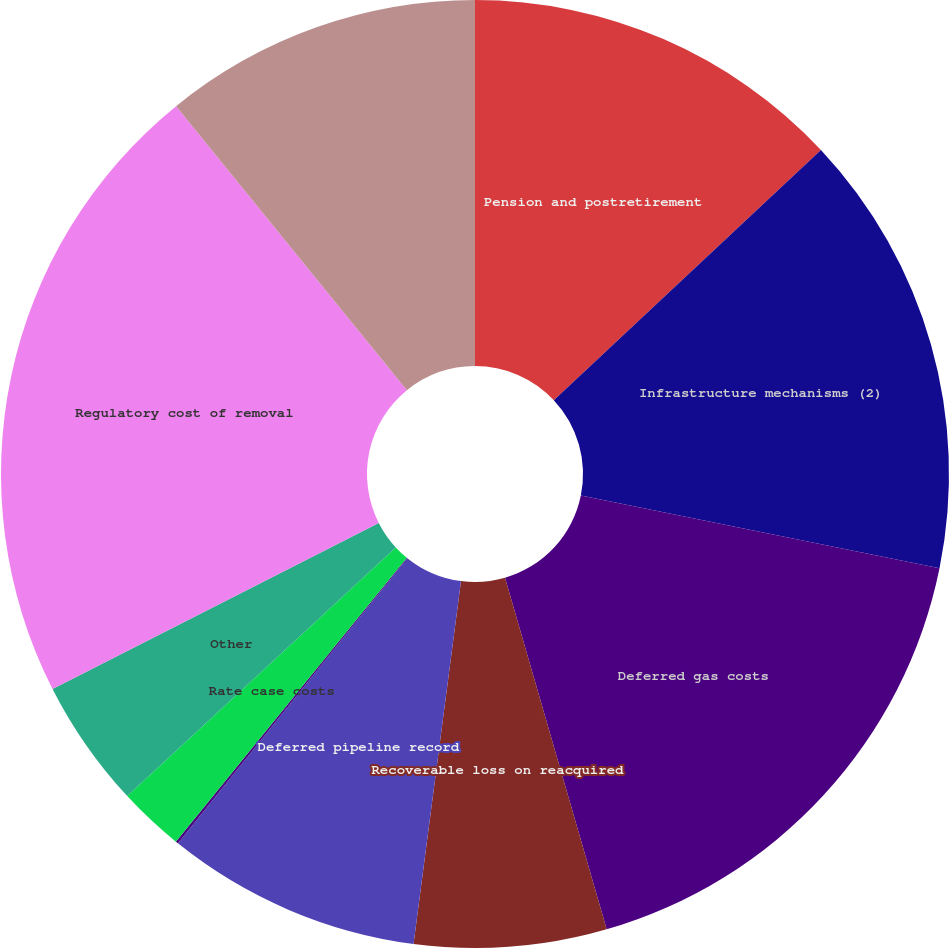Convert chart to OTSL. <chart><loc_0><loc_0><loc_500><loc_500><pie_chart><fcel>Pension and postretirement<fcel>Infrastructure mechanisms (2)<fcel>Deferred gas costs<fcel>Recoverable loss on reacquired<fcel>Deferred pipeline record<fcel>APT annual adjustment<fcel>Rate case costs<fcel>Other<fcel>Regulatory cost of removal<fcel>Asset retirement obligation<nl><fcel>13.02%<fcel>15.17%<fcel>17.33%<fcel>6.55%<fcel>8.71%<fcel>0.09%<fcel>2.24%<fcel>4.4%<fcel>21.63%<fcel>10.86%<nl></chart> 